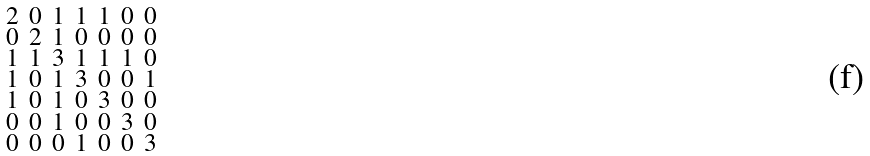Convert formula to latex. <formula><loc_0><loc_0><loc_500><loc_500>\begin{smallmatrix} 2 & 0 & 1 & 1 & 1 & 0 & 0 \\ 0 & 2 & 1 & 0 & 0 & 0 & 0 \\ 1 & 1 & 3 & 1 & 1 & 1 & 0 \\ 1 & 0 & 1 & 3 & 0 & 0 & 1 \\ 1 & 0 & 1 & 0 & 3 & 0 & 0 \\ 0 & 0 & 1 & 0 & 0 & 3 & 0 \\ 0 & 0 & 0 & 1 & 0 & 0 & 3 \end{smallmatrix}</formula> 